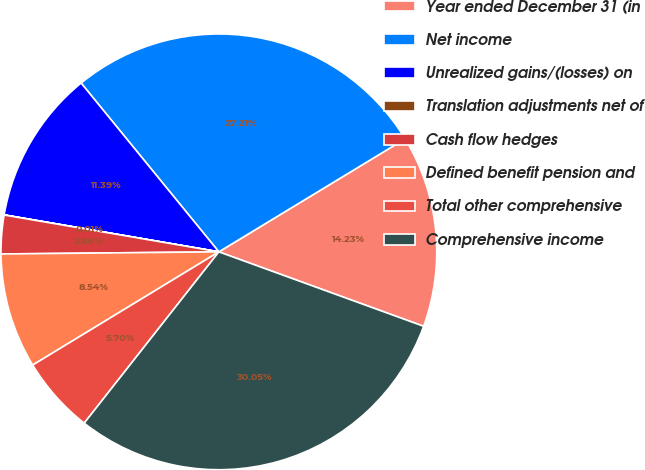Convert chart. <chart><loc_0><loc_0><loc_500><loc_500><pie_chart><fcel>Year ended December 31 (in<fcel>Net income<fcel>Unrealized gains/(losses) on<fcel>Translation adjustments net of<fcel>Cash flow hedges<fcel>Defined benefit pension and<fcel>Total other comprehensive<fcel>Comprehensive income<nl><fcel>14.23%<fcel>27.21%<fcel>11.39%<fcel>0.01%<fcel>2.86%<fcel>8.54%<fcel>5.7%<fcel>30.05%<nl></chart> 